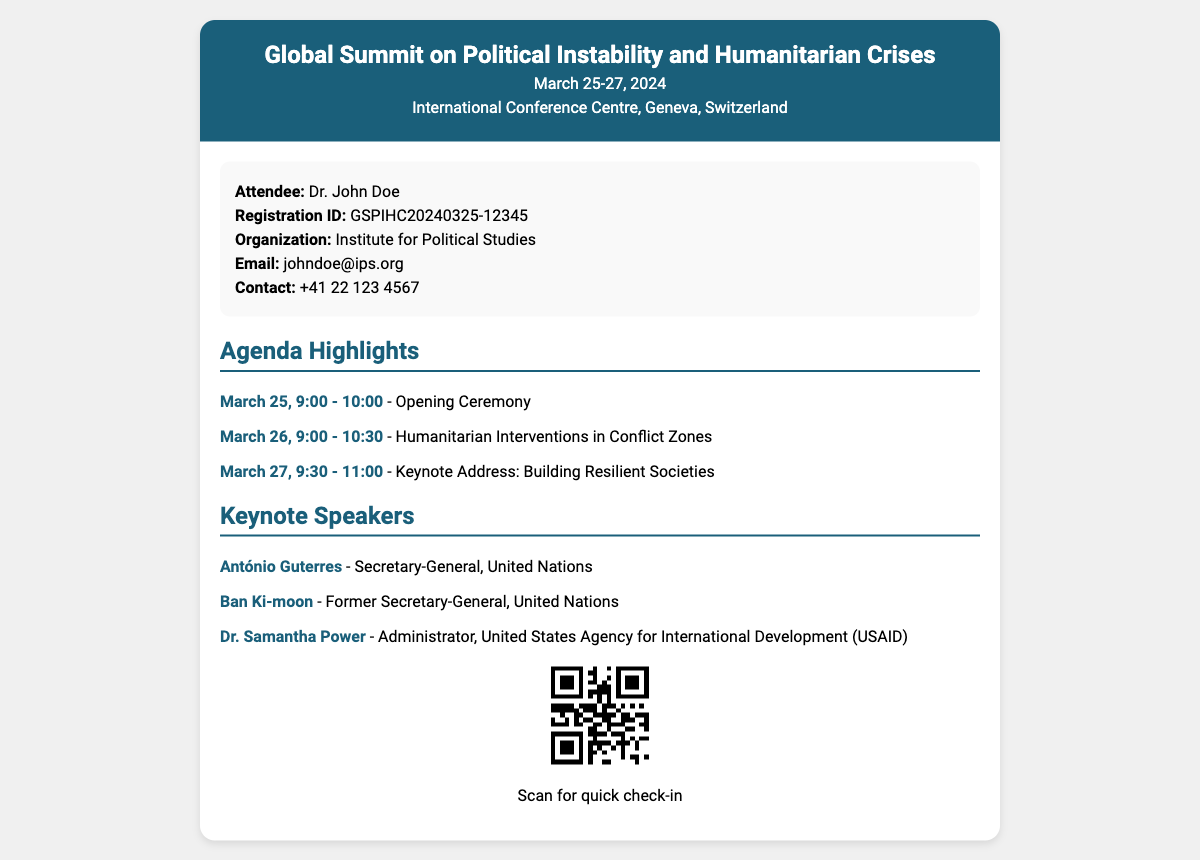What is the title of the conference? The title of the conference is stated prominently at the top of the document.
Answer: Global Summit on Political Instability and Humanitarian Crises What are the dates of the conference? The dates of the conference are mentioned next to the title in the header section.
Answer: March 25-27, 2024 Where is the conference venue? The venue is listed just below the dates in the ticket header.
Answer: International Conference Centre, Geneva, Switzerland Who is the attendee? The attendee's name is highlighted in the attendee information section.
Answer: Dr. John Doe What is the registration ID? The registration ID is specified in the attendee information section.
Answer: GSPIHC20240325-12345 What is the first agenda item? The first agenda item is mentioned in the agenda highlights section, detailing the event's schedule.
Answer: Opening Ceremony Who is the first keynote speaker? The first keynote speaker is listed in the keynote speakers section.
Answer: António Guterres What time does the last session start on March 27? The last session's starting time for that day is noted in the agenda highlights.
Answer: 9:30 AM What is the contact number for the attendee? The contact number for the attendee is provided in the information section.
Answer: +41 22 123 4567 